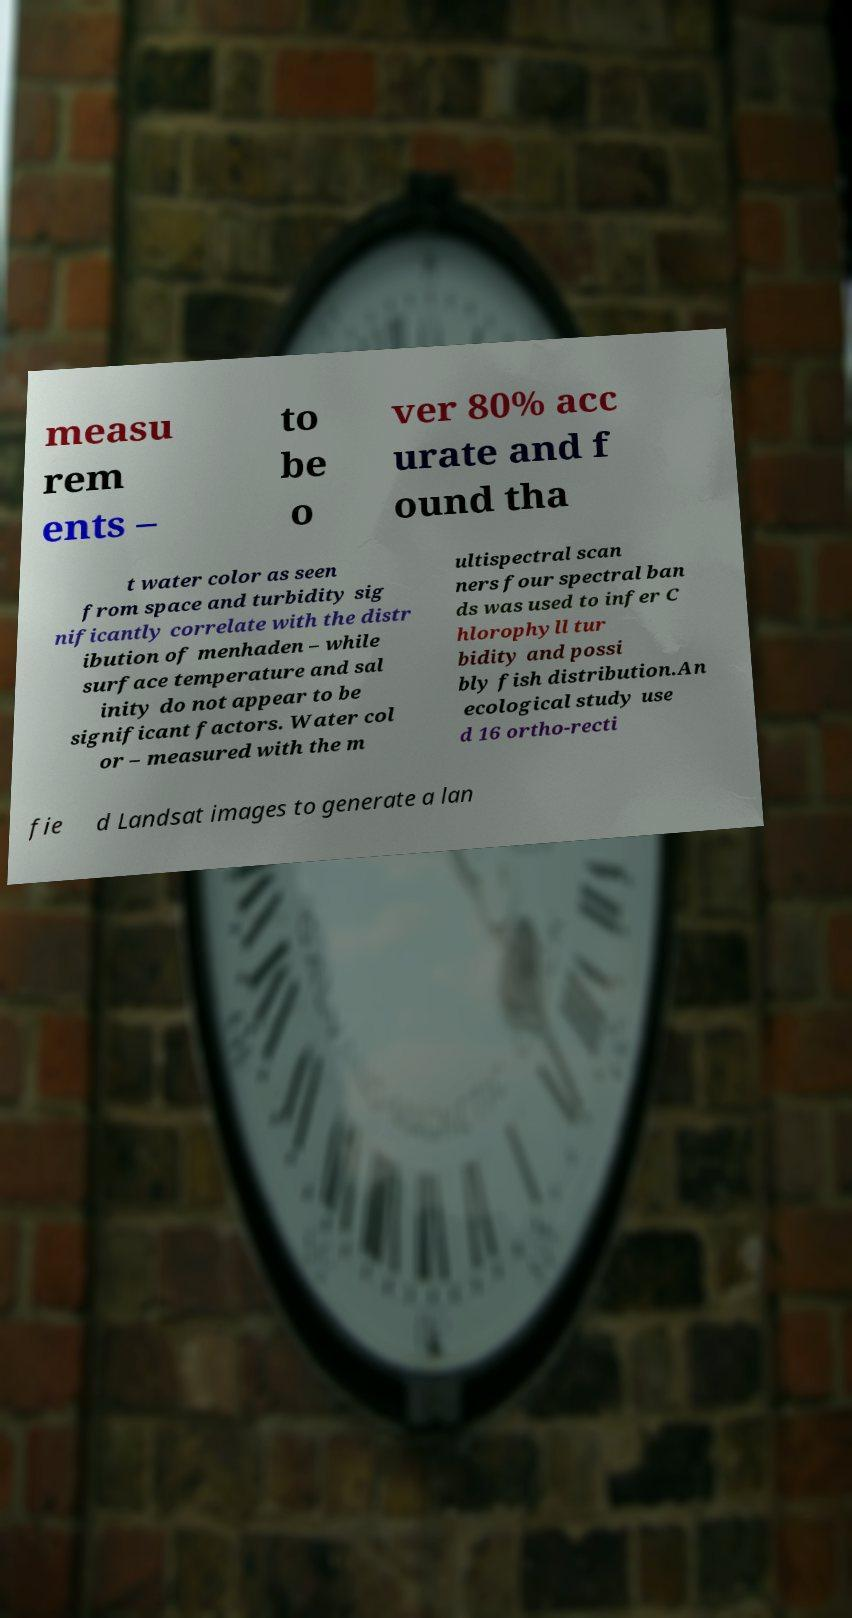Can you accurately transcribe the text from the provided image for me? measu rem ents – to be o ver 80% acc urate and f ound tha t water color as seen from space and turbidity sig nificantly correlate with the distr ibution of menhaden – while surface temperature and sal inity do not appear to be significant factors. Water col or – measured with the m ultispectral scan ners four spectral ban ds was used to infer C hlorophyll tur bidity and possi bly fish distribution.An ecological study use d 16 ortho-recti fie d Landsat images to generate a lan 